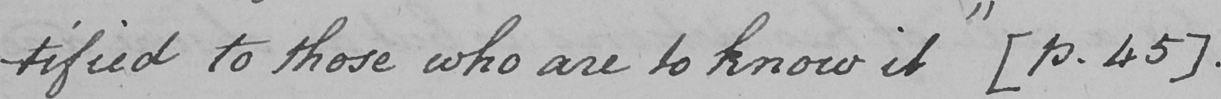What does this handwritten line say? -tified to those who are to know it "   [ p . 45 ]  . 